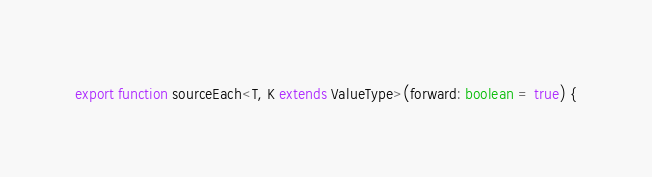<code> <loc_0><loc_0><loc_500><loc_500><_TypeScript_>
export function sourceEach<T, K extends ValueType>(forward: boolean = true) {</code> 